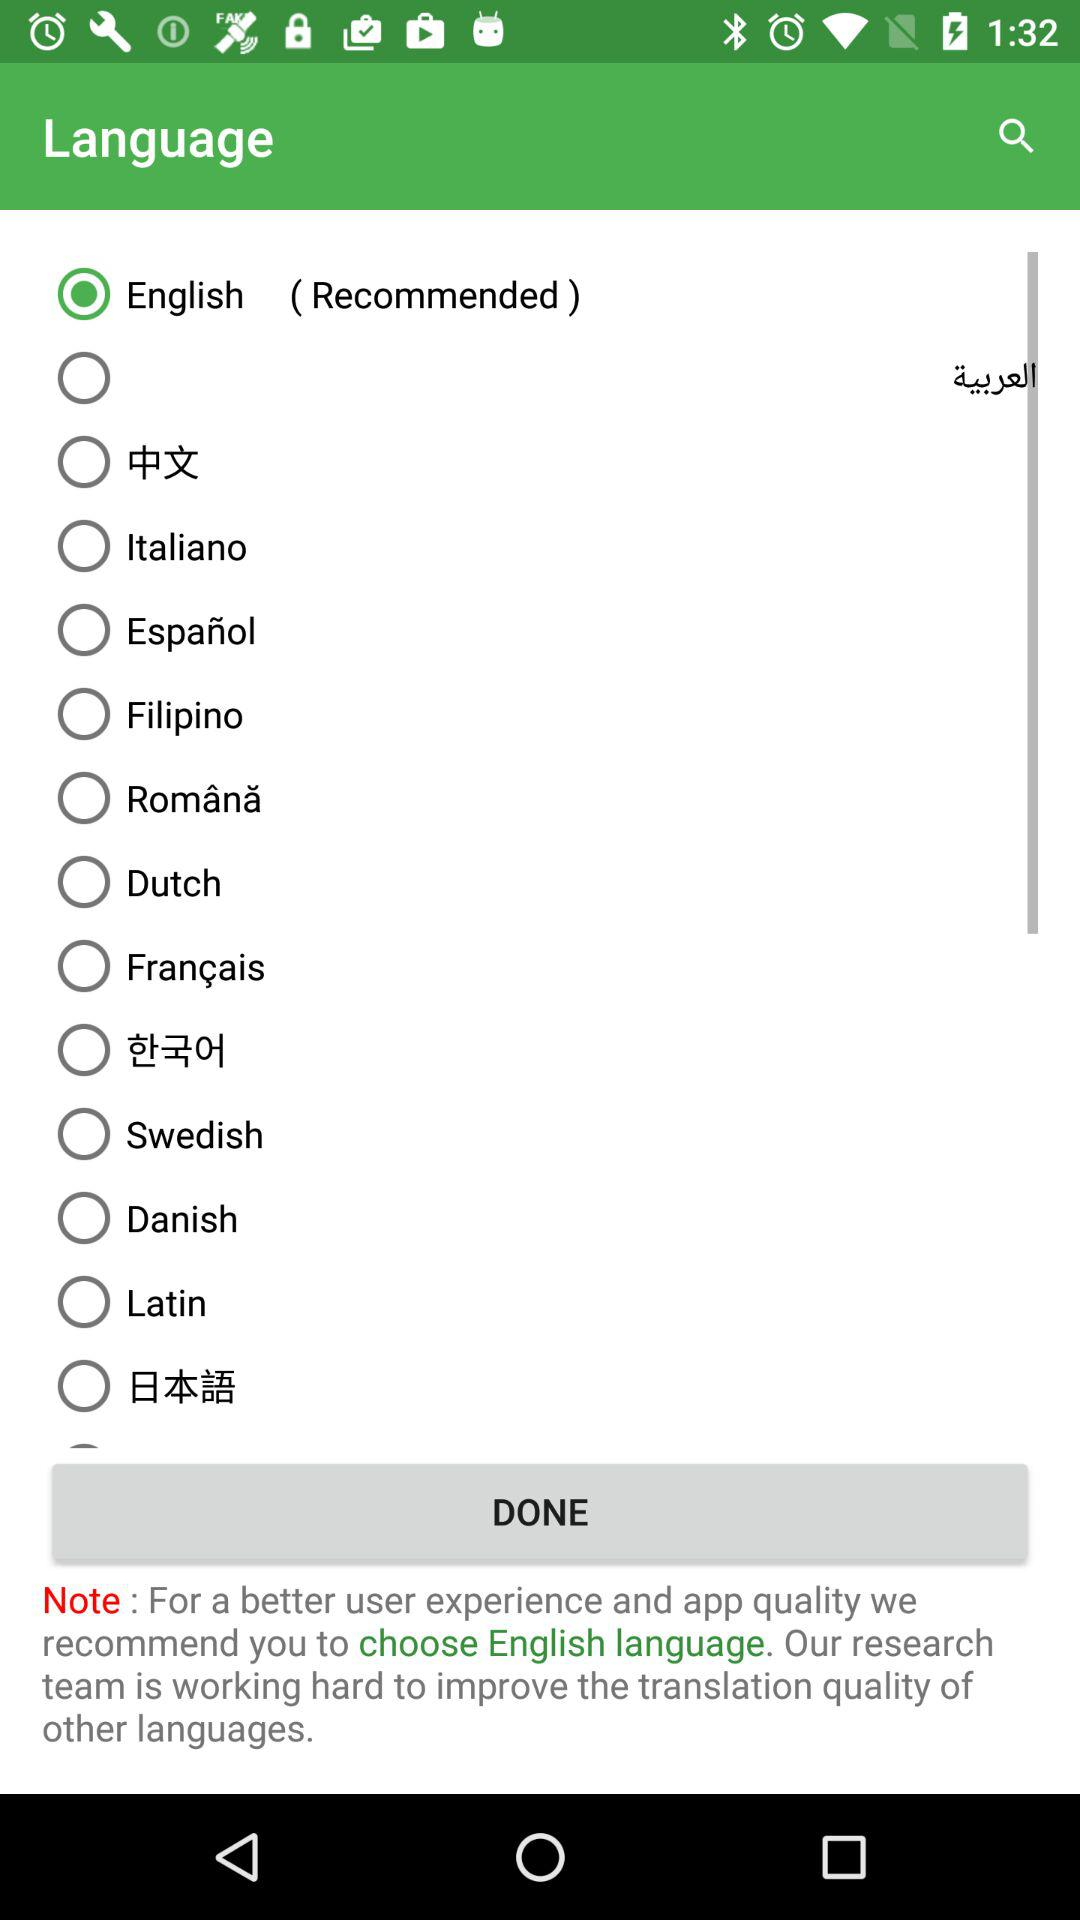What is the selected language? The selected language is English. 